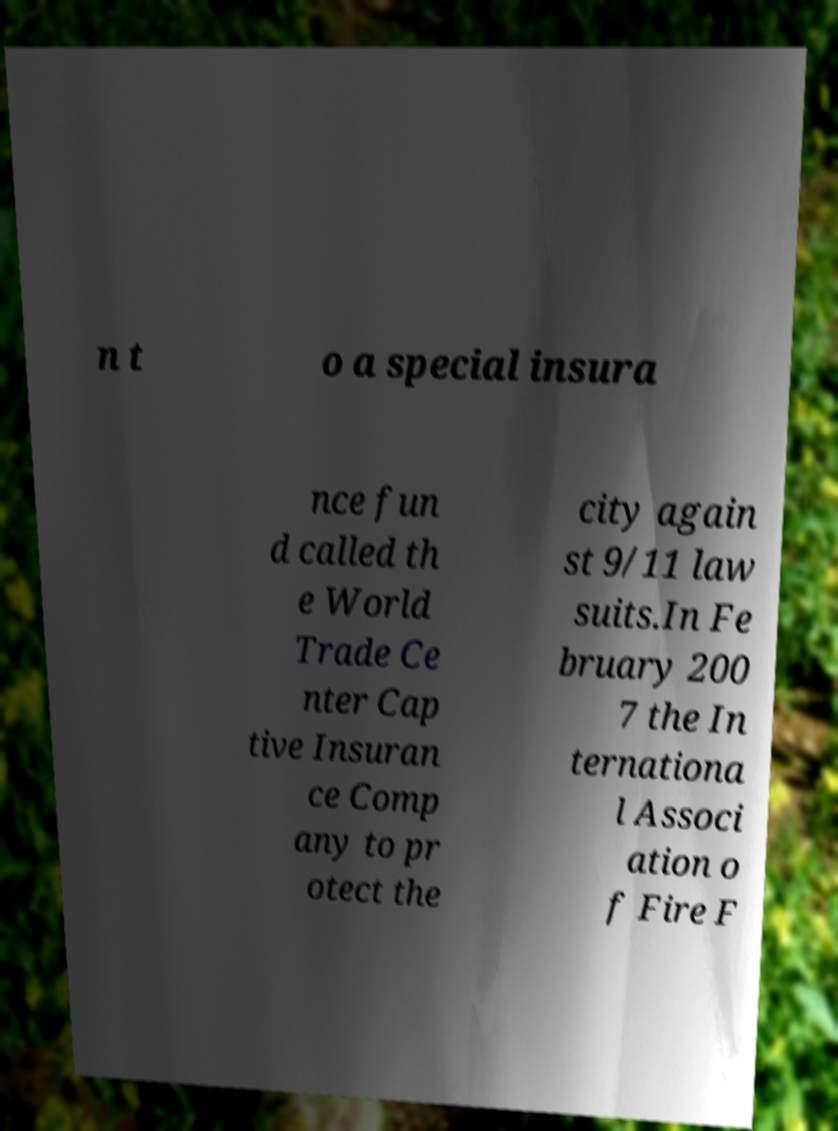Please read and relay the text visible in this image. What does it say? n t o a special insura nce fun d called th e World Trade Ce nter Cap tive Insuran ce Comp any to pr otect the city again st 9/11 law suits.In Fe bruary 200 7 the In ternationa l Associ ation o f Fire F 